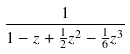<formula> <loc_0><loc_0><loc_500><loc_500>\frac { 1 } { 1 - z + \frac { 1 } { 2 } z ^ { 2 } - \frac { 1 } { 6 } z ^ { 3 } }</formula> 